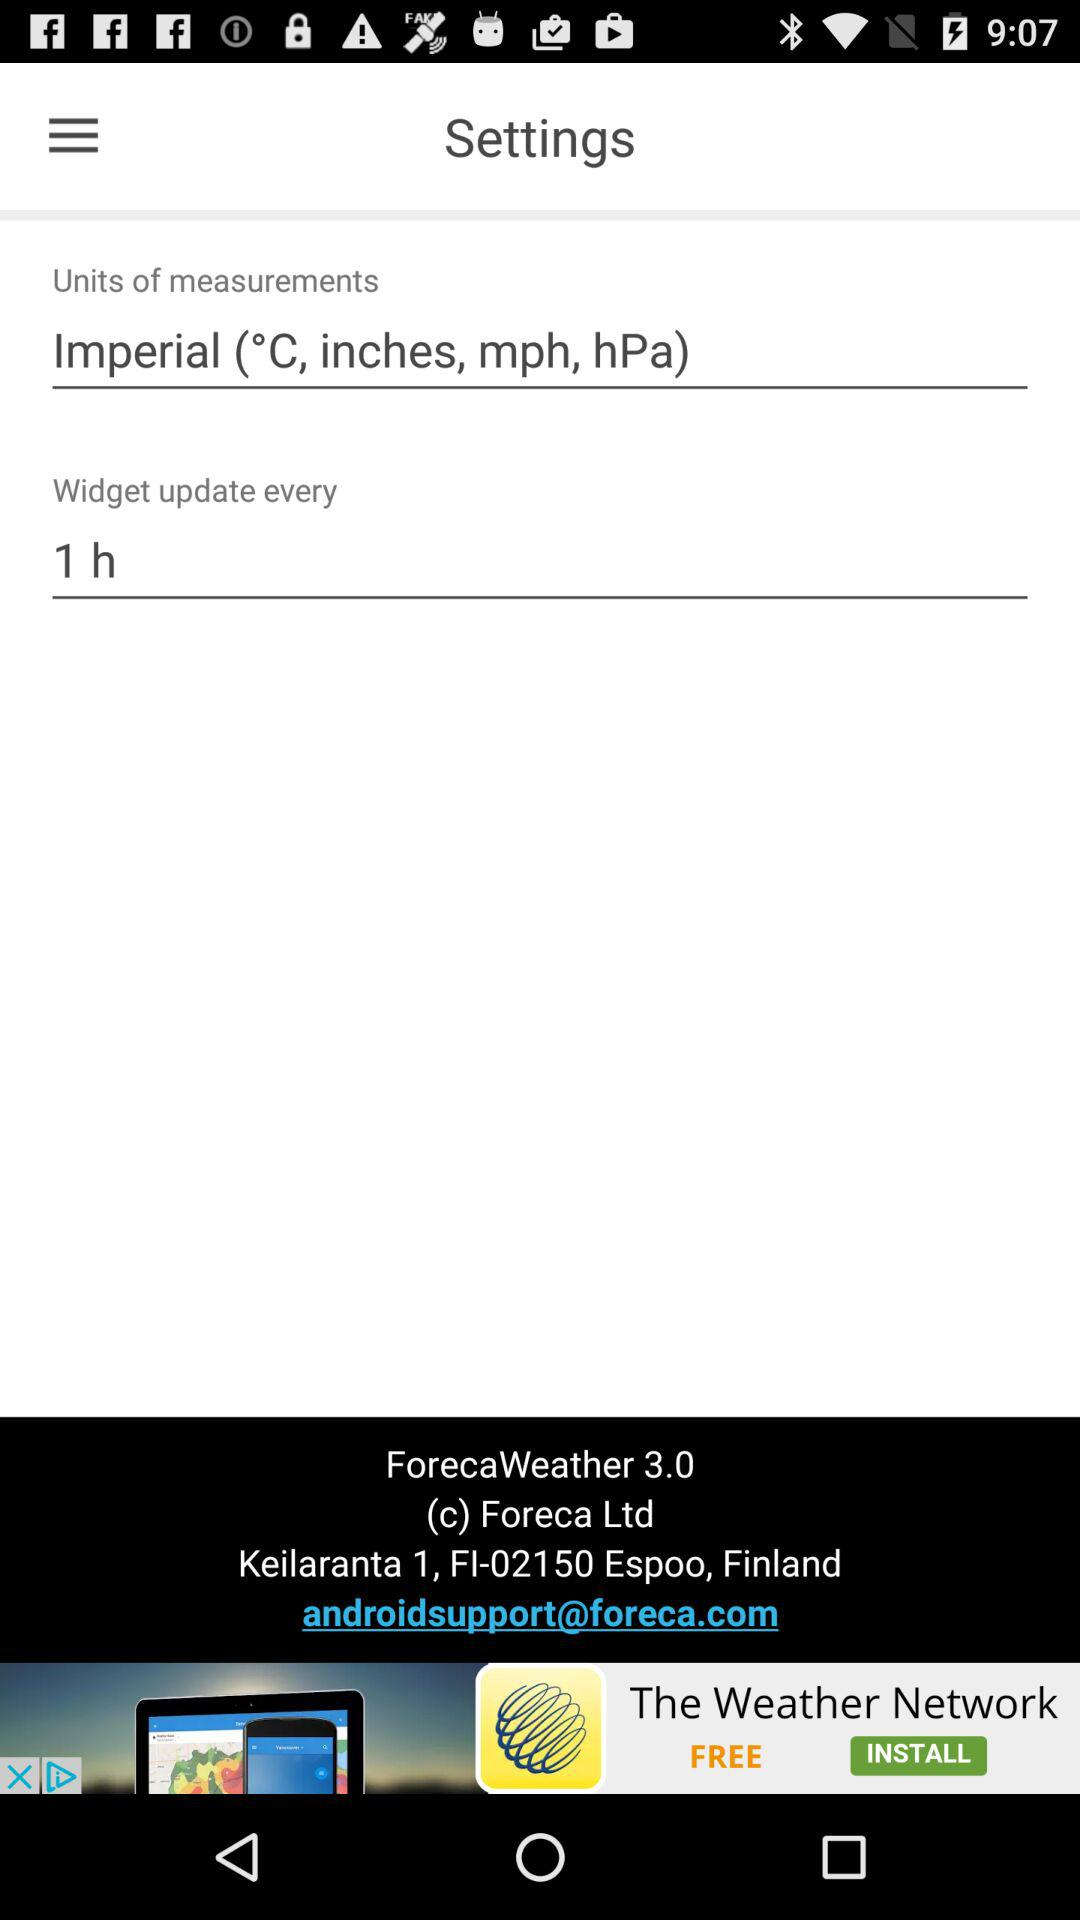How often does the widget update? It updates every hour. 